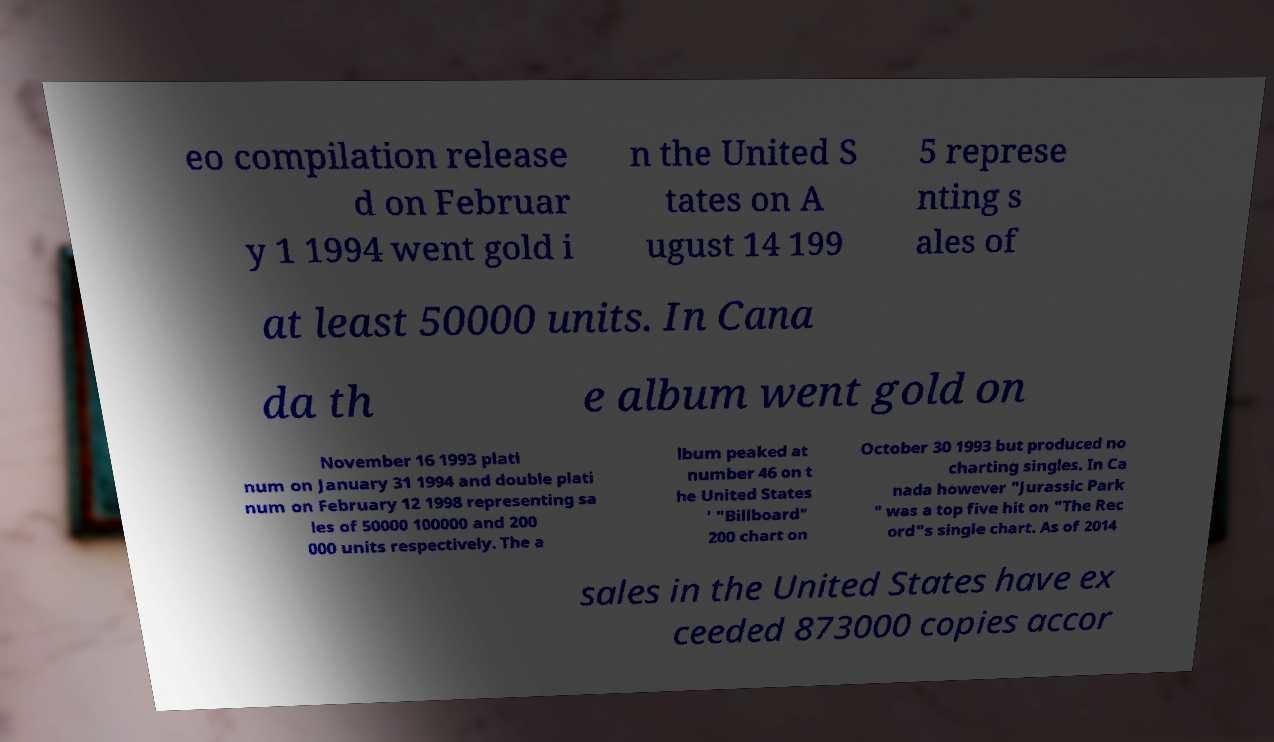For documentation purposes, I need the text within this image transcribed. Could you provide that? eo compilation release d on Februar y 1 1994 went gold i n the United S tates on A ugust 14 199 5 represe nting s ales of at least 50000 units. In Cana da th e album went gold on November 16 1993 plati num on January 31 1994 and double plati num on February 12 1998 representing sa les of 50000 100000 and 200 000 units respectively. The a lbum peaked at number 46 on t he United States ' "Billboard" 200 chart on October 30 1993 but produced no charting singles. In Ca nada however "Jurassic Park " was a top five hit on "The Rec ord"s single chart. As of 2014 sales in the United States have ex ceeded 873000 copies accor 